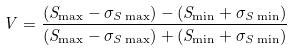Convert formula to latex. <formula><loc_0><loc_0><loc_500><loc_500>V = \frac { ( S _ { \max } - \sigma _ { S \max } ) - ( S _ { \min } + \sigma _ { S \min } ) } { ( S _ { \max } - \sigma _ { S \max } ) + ( S _ { \min } + \sigma _ { S \min } ) }</formula> 